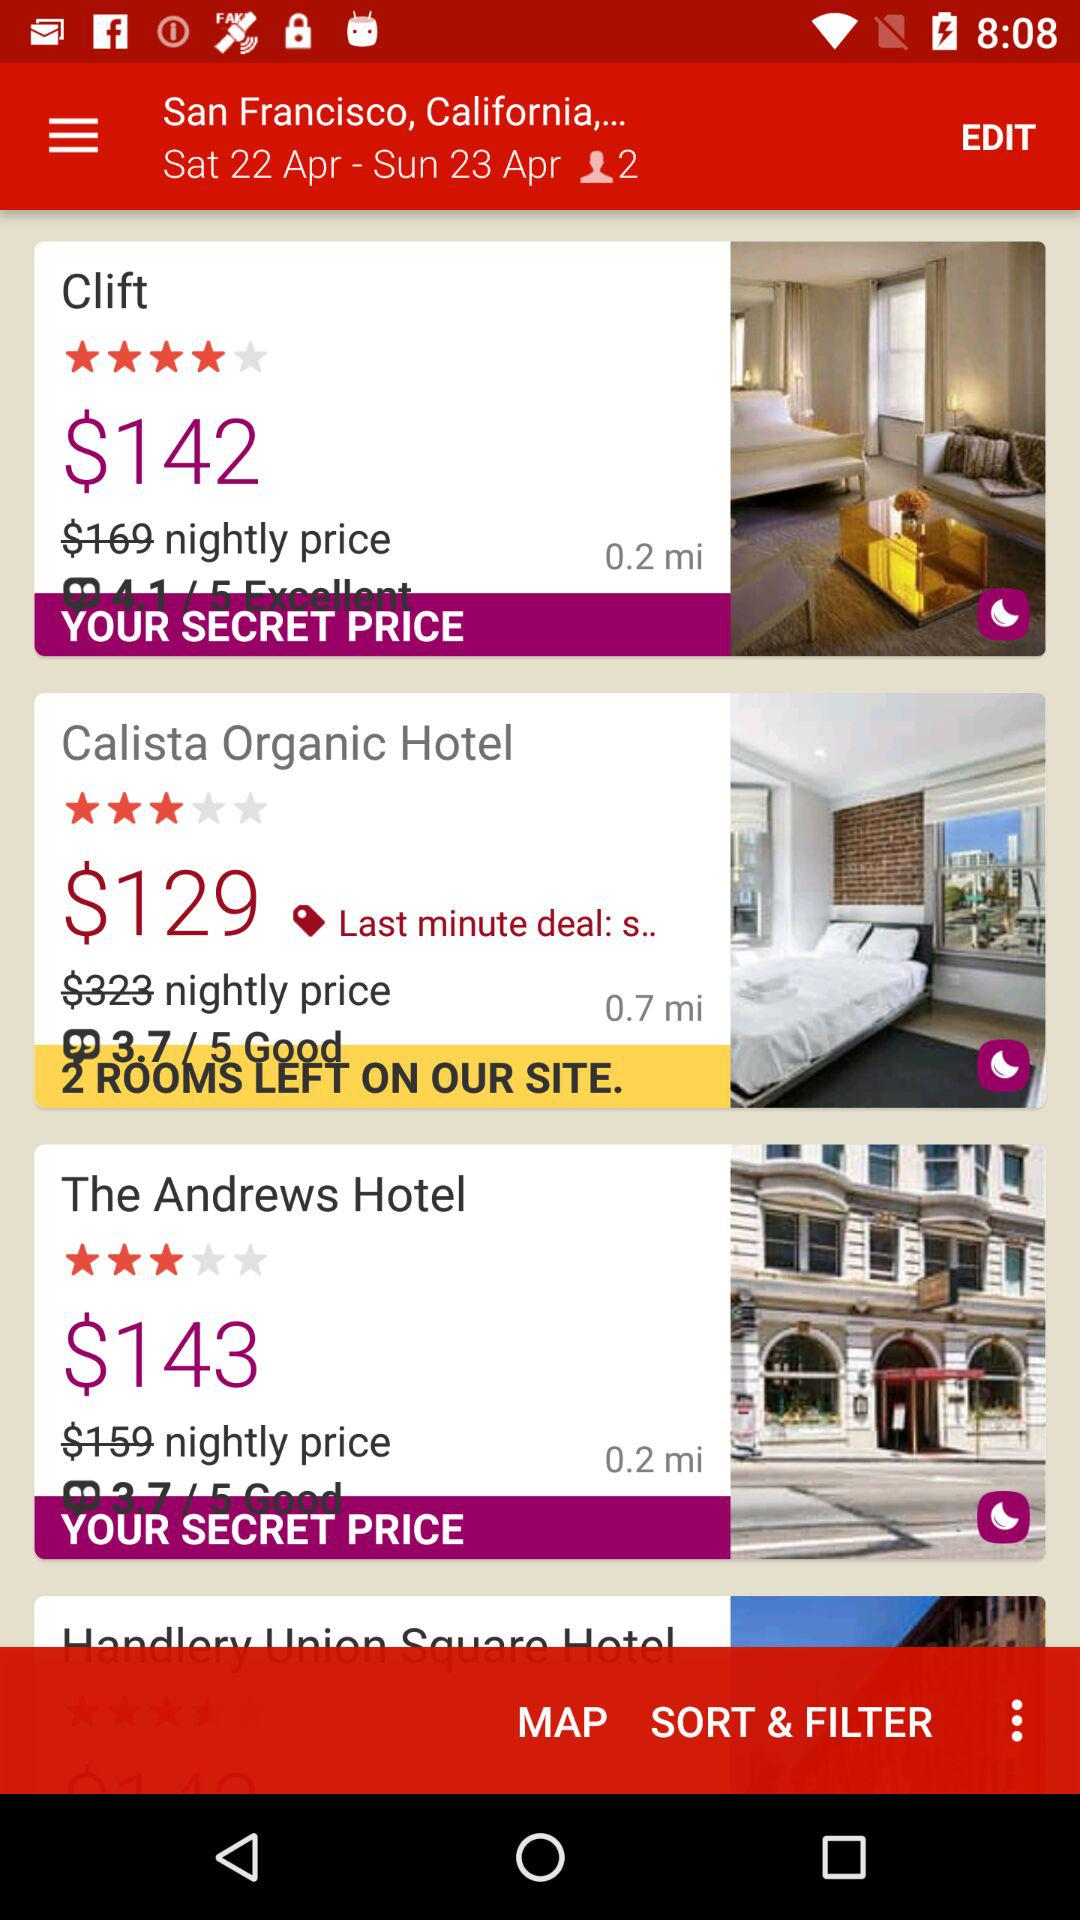What is the rating of the hotel "Clift" out of five? The rating of the hotel "Clift" out of five is 4 stars. 